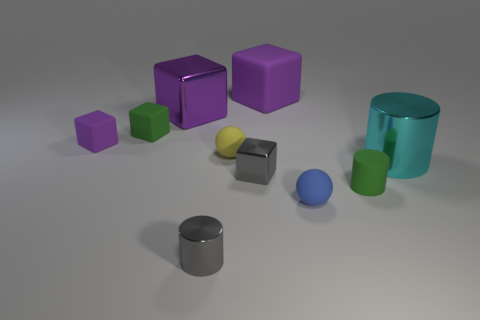Is the material of the green block the same as the gray thing in front of the rubber cylinder?
Keep it short and to the point. No. The large cylinder is what color?
Provide a short and direct response. Cyan. What number of green rubber cubes are left of the rubber cube behind the green cube that is in front of the purple metallic cube?
Provide a succinct answer. 1. Are there any balls behind the tiny shiny cube?
Your answer should be compact. Yes. How many small balls have the same material as the green cylinder?
Ensure brevity in your answer.  2. What number of things are either gray cylinders or yellow balls?
Provide a short and direct response. 2. Are any red metal spheres visible?
Make the answer very short. No. The green object behind the sphere behind the large shiny thing that is in front of the small purple rubber cube is made of what material?
Provide a short and direct response. Rubber. Are there fewer big purple shiny objects in front of the gray shiny cylinder than tiny metallic blocks?
Your answer should be very brief. Yes. There is another block that is the same size as the purple metallic block; what is its material?
Offer a very short reply. Rubber. 